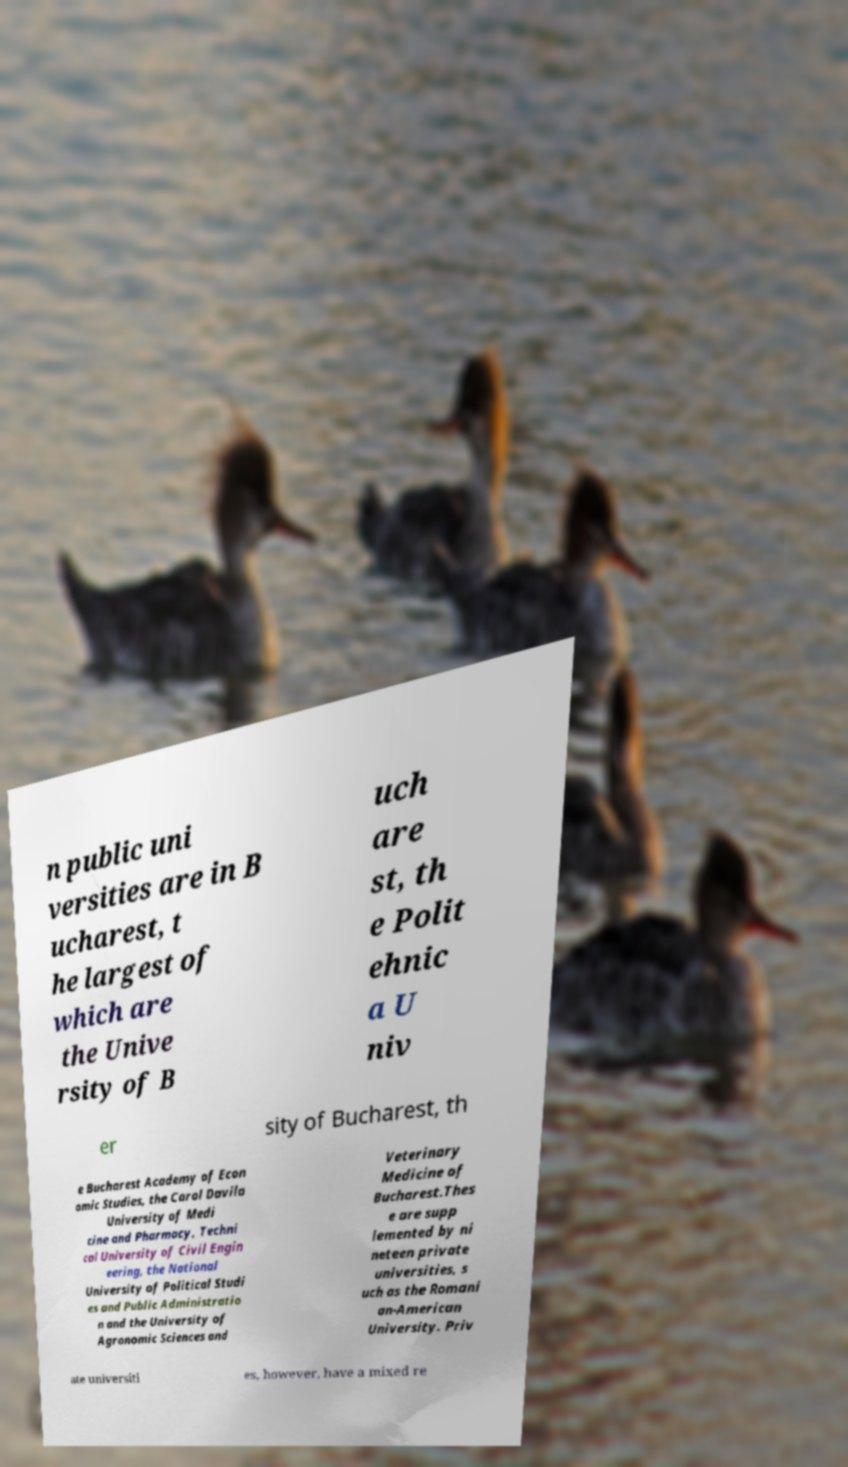Could you assist in decoding the text presented in this image and type it out clearly? n public uni versities are in B ucharest, t he largest of which are the Unive rsity of B uch are st, th e Polit ehnic a U niv er sity of Bucharest, th e Bucharest Academy of Econ omic Studies, the Carol Davila University of Medi cine and Pharmacy, Techni cal University of Civil Engin eering, the National University of Political Studi es and Public Administratio n and the University of Agronomic Sciences and Veterinary Medicine of Bucharest.Thes e are supp lemented by ni neteen private universities, s uch as the Romani an-American University. Priv ate universiti es, however, have a mixed re 